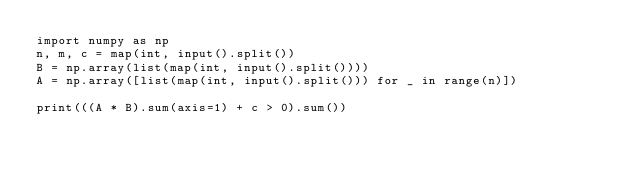<code> <loc_0><loc_0><loc_500><loc_500><_Python_>import numpy as np
n, m, c = map(int, input().split())
B = np.array(list(map(int, input().split())))
A = np.array([list(map(int, input().split())) for _ in range(n)])

print(((A * B).sum(axis=1) + c > 0).sum())</code> 